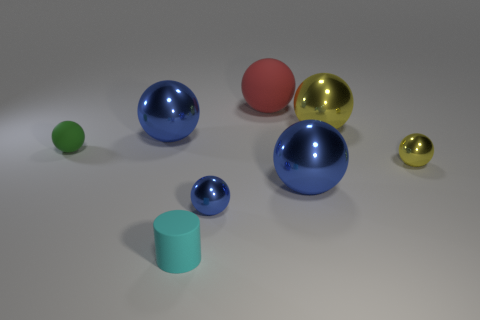Subtract all red cylinders. Subtract all cyan cubes. How many cylinders are left? 1 Subtract all green blocks. How many gray cylinders are left? 0 Add 5 tiny reds. How many large things exist? 0 Subtract all yellow metallic cylinders. Subtract all tiny cyan matte cylinders. How many objects are left? 7 Add 8 large blue metallic things. How many large blue metallic things are left? 10 Add 8 green cylinders. How many green cylinders exist? 8 Add 2 small blue things. How many objects exist? 10 Subtract all blue balls. How many balls are left? 4 Subtract all matte balls. How many balls are left? 5 Subtract 0 blue cylinders. How many objects are left? 8 